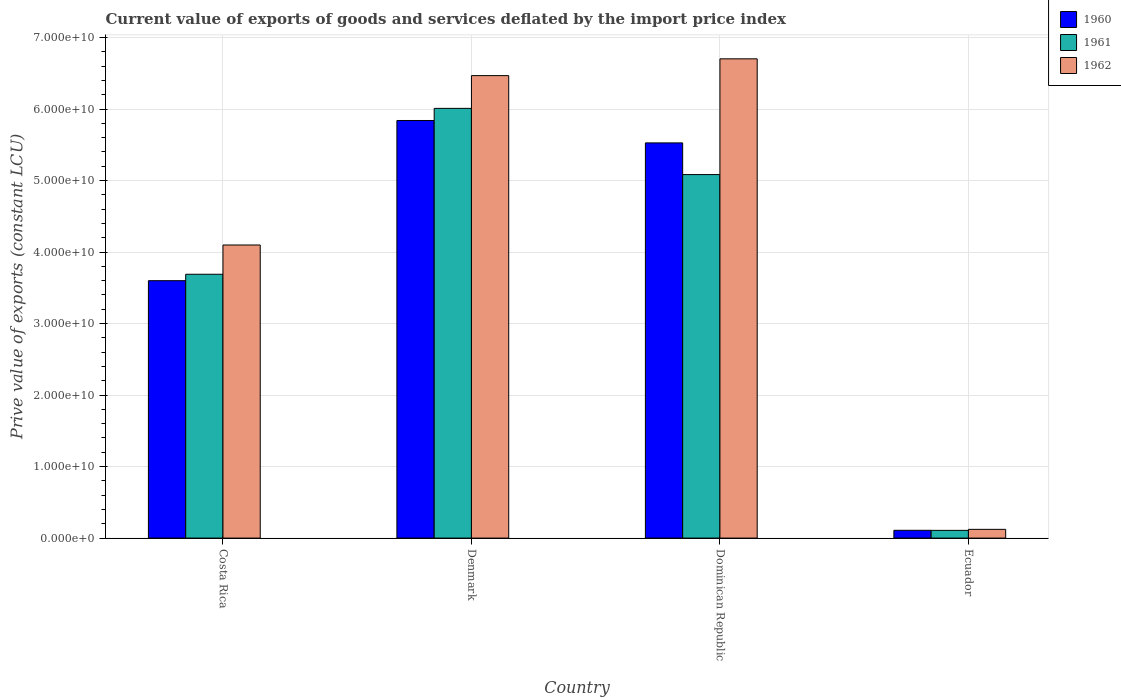Are the number of bars per tick equal to the number of legend labels?
Your answer should be very brief. Yes. Are the number of bars on each tick of the X-axis equal?
Provide a succinct answer. Yes. How many bars are there on the 3rd tick from the left?
Keep it short and to the point. 3. What is the label of the 4th group of bars from the left?
Make the answer very short. Ecuador. In how many cases, is the number of bars for a given country not equal to the number of legend labels?
Keep it short and to the point. 0. What is the prive value of exports in 1960 in Dominican Republic?
Provide a short and direct response. 5.53e+1. Across all countries, what is the maximum prive value of exports in 1962?
Offer a very short reply. 6.70e+1. Across all countries, what is the minimum prive value of exports in 1962?
Offer a very short reply. 1.22e+09. In which country was the prive value of exports in 1961 maximum?
Ensure brevity in your answer.  Denmark. In which country was the prive value of exports in 1962 minimum?
Offer a very short reply. Ecuador. What is the total prive value of exports in 1961 in the graph?
Your answer should be compact. 1.49e+11. What is the difference between the prive value of exports in 1960 in Denmark and that in Dominican Republic?
Offer a very short reply. 3.13e+09. What is the difference between the prive value of exports in 1960 in Denmark and the prive value of exports in 1962 in Costa Rica?
Make the answer very short. 1.74e+1. What is the average prive value of exports in 1960 per country?
Your answer should be compact. 3.77e+1. What is the difference between the prive value of exports of/in 1960 and prive value of exports of/in 1962 in Costa Rica?
Keep it short and to the point. -4.99e+09. What is the ratio of the prive value of exports in 1960 in Costa Rica to that in Ecuador?
Your answer should be compact. 33.09. Is the prive value of exports in 1962 in Costa Rica less than that in Denmark?
Give a very brief answer. Yes. What is the difference between the highest and the second highest prive value of exports in 1962?
Keep it short and to the point. 2.37e+1. What is the difference between the highest and the lowest prive value of exports in 1960?
Offer a very short reply. 5.73e+1. What does the 1st bar from the right in Denmark represents?
Provide a short and direct response. 1962. Is it the case that in every country, the sum of the prive value of exports in 1962 and prive value of exports in 1960 is greater than the prive value of exports in 1961?
Make the answer very short. Yes. How many bars are there?
Your answer should be very brief. 12. What is the difference between two consecutive major ticks on the Y-axis?
Give a very brief answer. 1.00e+1. Where does the legend appear in the graph?
Give a very brief answer. Top right. How are the legend labels stacked?
Give a very brief answer. Vertical. What is the title of the graph?
Give a very brief answer. Current value of exports of goods and services deflated by the import price index. Does "1984" appear as one of the legend labels in the graph?
Your response must be concise. No. What is the label or title of the X-axis?
Give a very brief answer. Country. What is the label or title of the Y-axis?
Your answer should be very brief. Prive value of exports (constant LCU). What is the Prive value of exports (constant LCU) of 1960 in Costa Rica?
Offer a very short reply. 3.60e+1. What is the Prive value of exports (constant LCU) in 1961 in Costa Rica?
Ensure brevity in your answer.  3.69e+1. What is the Prive value of exports (constant LCU) in 1962 in Costa Rica?
Offer a terse response. 4.10e+1. What is the Prive value of exports (constant LCU) in 1960 in Denmark?
Make the answer very short. 5.84e+1. What is the Prive value of exports (constant LCU) in 1961 in Denmark?
Your answer should be compact. 6.01e+1. What is the Prive value of exports (constant LCU) in 1962 in Denmark?
Offer a very short reply. 6.47e+1. What is the Prive value of exports (constant LCU) of 1960 in Dominican Republic?
Provide a succinct answer. 5.53e+1. What is the Prive value of exports (constant LCU) of 1961 in Dominican Republic?
Keep it short and to the point. 5.08e+1. What is the Prive value of exports (constant LCU) of 1962 in Dominican Republic?
Ensure brevity in your answer.  6.70e+1. What is the Prive value of exports (constant LCU) of 1960 in Ecuador?
Your answer should be very brief. 1.09e+09. What is the Prive value of exports (constant LCU) in 1961 in Ecuador?
Your response must be concise. 1.08e+09. What is the Prive value of exports (constant LCU) in 1962 in Ecuador?
Your response must be concise. 1.22e+09. Across all countries, what is the maximum Prive value of exports (constant LCU) in 1960?
Provide a succinct answer. 5.84e+1. Across all countries, what is the maximum Prive value of exports (constant LCU) in 1961?
Your answer should be compact. 6.01e+1. Across all countries, what is the maximum Prive value of exports (constant LCU) in 1962?
Your response must be concise. 6.70e+1. Across all countries, what is the minimum Prive value of exports (constant LCU) in 1960?
Ensure brevity in your answer.  1.09e+09. Across all countries, what is the minimum Prive value of exports (constant LCU) of 1961?
Provide a short and direct response. 1.08e+09. Across all countries, what is the minimum Prive value of exports (constant LCU) of 1962?
Make the answer very short. 1.22e+09. What is the total Prive value of exports (constant LCU) in 1960 in the graph?
Ensure brevity in your answer.  1.51e+11. What is the total Prive value of exports (constant LCU) in 1961 in the graph?
Keep it short and to the point. 1.49e+11. What is the total Prive value of exports (constant LCU) in 1962 in the graph?
Offer a very short reply. 1.74e+11. What is the difference between the Prive value of exports (constant LCU) of 1960 in Costa Rica and that in Denmark?
Offer a terse response. -2.24e+1. What is the difference between the Prive value of exports (constant LCU) in 1961 in Costa Rica and that in Denmark?
Give a very brief answer. -2.32e+1. What is the difference between the Prive value of exports (constant LCU) in 1962 in Costa Rica and that in Denmark?
Ensure brevity in your answer.  -2.37e+1. What is the difference between the Prive value of exports (constant LCU) of 1960 in Costa Rica and that in Dominican Republic?
Offer a terse response. -1.93e+1. What is the difference between the Prive value of exports (constant LCU) in 1961 in Costa Rica and that in Dominican Republic?
Make the answer very short. -1.39e+1. What is the difference between the Prive value of exports (constant LCU) of 1962 in Costa Rica and that in Dominican Republic?
Make the answer very short. -2.60e+1. What is the difference between the Prive value of exports (constant LCU) in 1960 in Costa Rica and that in Ecuador?
Your answer should be compact. 3.49e+1. What is the difference between the Prive value of exports (constant LCU) of 1961 in Costa Rica and that in Ecuador?
Offer a terse response. 3.58e+1. What is the difference between the Prive value of exports (constant LCU) in 1962 in Costa Rica and that in Ecuador?
Provide a succinct answer. 3.98e+1. What is the difference between the Prive value of exports (constant LCU) in 1960 in Denmark and that in Dominican Republic?
Keep it short and to the point. 3.13e+09. What is the difference between the Prive value of exports (constant LCU) in 1961 in Denmark and that in Dominican Republic?
Make the answer very short. 9.26e+09. What is the difference between the Prive value of exports (constant LCU) of 1962 in Denmark and that in Dominican Republic?
Your answer should be very brief. -2.35e+09. What is the difference between the Prive value of exports (constant LCU) in 1960 in Denmark and that in Ecuador?
Make the answer very short. 5.73e+1. What is the difference between the Prive value of exports (constant LCU) in 1961 in Denmark and that in Ecuador?
Provide a succinct answer. 5.90e+1. What is the difference between the Prive value of exports (constant LCU) in 1962 in Denmark and that in Ecuador?
Keep it short and to the point. 6.35e+1. What is the difference between the Prive value of exports (constant LCU) of 1960 in Dominican Republic and that in Ecuador?
Provide a short and direct response. 5.42e+1. What is the difference between the Prive value of exports (constant LCU) in 1961 in Dominican Republic and that in Ecuador?
Your response must be concise. 4.98e+1. What is the difference between the Prive value of exports (constant LCU) in 1962 in Dominican Republic and that in Ecuador?
Your answer should be very brief. 6.58e+1. What is the difference between the Prive value of exports (constant LCU) in 1960 in Costa Rica and the Prive value of exports (constant LCU) in 1961 in Denmark?
Your answer should be compact. -2.41e+1. What is the difference between the Prive value of exports (constant LCU) of 1960 in Costa Rica and the Prive value of exports (constant LCU) of 1962 in Denmark?
Provide a succinct answer. -2.87e+1. What is the difference between the Prive value of exports (constant LCU) in 1961 in Costa Rica and the Prive value of exports (constant LCU) in 1962 in Denmark?
Provide a short and direct response. -2.78e+1. What is the difference between the Prive value of exports (constant LCU) of 1960 in Costa Rica and the Prive value of exports (constant LCU) of 1961 in Dominican Republic?
Offer a terse response. -1.48e+1. What is the difference between the Prive value of exports (constant LCU) of 1960 in Costa Rica and the Prive value of exports (constant LCU) of 1962 in Dominican Republic?
Offer a very short reply. -3.10e+1. What is the difference between the Prive value of exports (constant LCU) of 1961 in Costa Rica and the Prive value of exports (constant LCU) of 1962 in Dominican Republic?
Ensure brevity in your answer.  -3.01e+1. What is the difference between the Prive value of exports (constant LCU) of 1960 in Costa Rica and the Prive value of exports (constant LCU) of 1961 in Ecuador?
Keep it short and to the point. 3.49e+1. What is the difference between the Prive value of exports (constant LCU) in 1960 in Costa Rica and the Prive value of exports (constant LCU) in 1962 in Ecuador?
Make the answer very short. 3.48e+1. What is the difference between the Prive value of exports (constant LCU) of 1961 in Costa Rica and the Prive value of exports (constant LCU) of 1962 in Ecuador?
Give a very brief answer. 3.57e+1. What is the difference between the Prive value of exports (constant LCU) of 1960 in Denmark and the Prive value of exports (constant LCU) of 1961 in Dominican Republic?
Make the answer very short. 7.57e+09. What is the difference between the Prive value of exports (constant LCU) of 1960 in Denmark and the Prive value of exports (constant LCU) of 1962 in Dominican Republic?
Your answer should be compact. -8.62e+09. What is the difference between the Prive value of exports (constant LCU) in 1961 in Denmark and the Prive value of exports (constant LCU) in 1962 in Dominican Republic?
Your response must be concise. -6.93e+09. What is the difference between the Prive value of exports (constant LCU) of 1960 in Denmark and the Prive value of exports (constant LCU) of 1961 in Ecuador?
Ensure brevity in your answer.  5.73e+1. What is the difference between the Prive value of exports (constant LCU) of 1960 in Denmark and the Prive value of exports (constant LCU) of 1962 in Ecuador?
Your answer should be very brief. 5.72e+1. What is the difference between the Prive value of exports (constant LCU) in 1961 in Denmark and the Prive value of exports (constant LCU) in 1962 in Ecuador?
Give a very brief answer. 5.89e+1. What is the difference between the Prive value of exports (constant LCU) in 1960 in Dominican Republic and the Prive value of exports (constant LCU) in 1961 in Ecuador?
Offer a terse response. 5.42e+1. What is the difference between the Prive value of exports (constant LCU) of 1960 in Dominican Republic and the Prive value of exports (constant LCU) of 1962 in Ecuador?
Offer a terse response. 5.40e+1. What is the difference between the Prive value of exports (constant LCU) of 1961 in Dominican Republic and the Prive value of exports (constant LCU) of 1962 in Ecuador?
Offer a terse response. 4.96e+1. What is the average Prive value of exports (constant LCU) of 1960 per country?
Offer a very short reply. 3.77e+1. What is the average Prive value of exports (constant LCU) of 1961 per country?
Your answer should be compact. 3.72e+1. What is the average Prive value of exports (constant LCU) of 1962 per country?
Provide a succinct answer. 4.35e+1. What is the difference between the Prive value of exports (constant LCU) of 1960 and Prive value of exports (constant LCU) of 1961 in Costa Rica?
Your response must be concise. -8.99e+08. What is the difference between the Prive value of exports (constant LCU) of 1960 and Prive value of exports (constant LCU) of 1962 in Costa Rica?
Give a very brief answer. -4.99e+09. What is the difference between the Prive value of exports (constant LCU) in 1961 and Prive value of exports (constant LCU) in 1962 in Costa Rica?
Offer a terse response. -4.09e+09. What is the difference between the Prive value of exports (constant LCU) in 1960 and Prive value of exports (constant LCU) in 1961 in Denmark?
Ensure brevity in your answer.  -1.70e+09. What is the difference between the Prive value of exports (constant LCU) in 1960 and Prive value of exports (constant LCU) in 1962 in Denmark?
Ensure brevity in your answer.  -6.28e+09. What is the difference between the Prive value of exports (constant LCU) of 1961 and Prive value of exports (constant LCU) of 1962 in Denmark?
Ensure brevity in your answer.  -4.58e+09. What is the difference between the Prive value of exports (constant LCU) of 1960 and Prive value of exports (constant LCU) of 1961 in Dominican Republic?
Your answer should be compact. 4.43e+09. What is the difference between the Prive value of exports (constant LCU) of 1960 and Prive value of exports (constant LCU) of 1962 in Dominican Republic?
Offer a very short reply. -1.18e+1. What is the difference between the Prive value of exports (constant LCU) of 1961 and Prive value of exports (constant LCU) of 1962 in Dominican Republic?
Your response must be concise. -1.62e+1. What is the difference between the Prive value of exports (constant LCU) in 1960 and Prive value of exports (constant LCU) in 1961 in Ecuador?
Keep it short and to the point. 7.73e+06. What is the difference between the Prive value of exports (constant LCU) of 1960 and Prive value of exports (constant LCU) of 1962 in Ecuador?
Provide a short and direct response. -1.34e+08. What is the difference between the Prive value of exports (constant LCU) in 1961 and Prive value of exports (constant LCU) in 1962 in Ecuador?
Offer a terse response. -1.41e+08. What is the ratio of the Prive value of exports (constant LCU) in 1960 in Costa Rica to that in Denmark?
Your answer should be very brief. 0.62. What is the ratio of the Prive value of exports (constant LCU) in 1961 in Costa Rica to that in Denmark?
Give a very brief answer. 0.61. What is the ratio of the Prive value of exports (constant LCU) of 1962 in Costa Rica to that in Denmark?
Ensure brevity in your answer.  0.63. What is the ratio of the Prive value of exports (constant LCU) of 1960 in Costa Rica to that in Dominican Republic?
Give a very brief answer. 0.65. What is the ratio of the Prive value of exports (constant LCU) in 1961 in Costa Rica to that in Dominican Republic?
Offer a very short reply. 0.73. What is the ratio of the Prive value of exports (constant LCU) in 1962 in Costa Rica to that in Dominican Republic?
Provide a succinct answer. 0.61. What is the ratio of the Prive value of exports (constant LCU) of 1960 in Costa Rica to that in Ecuador?
Provide a succinct answer. 33.09. What is the ratio of the Prive value of exports (constant LCU) of 1961 in Costa Rica to that in Ecuador?
Your answer should be compact. 34.15. What is the ratio of the Prive value of exports (constant LCU) in 1962 in Costa Rica to that in Ecuador?
Your answer should be very brief. 33.55. What is the ratio of the Prive value of exports (constant LCU) of 1960 in Denmark to that in Dominican Republic?
Your answer should be compact. 1.06. What is the ratio of the Prive value of exports (constant LCU) of 1961 in Denmark to that in Dominican Republic?
Keep it short and to the point. 1.18. What is the ratio of the Prive value of exports (constant LCU) in 1962 in Denmark to that in Dominican Republic?
Ensure brevity in your answer.  0.96. What is the ratio of the Prive value of exports (constant LCU) of 1960 in Denmark to that in Ecuador?
Ensure brevity in your answer.  53.67. What is the ratio of the Prive value of exports (constant LCU) of 1961 in Denmark to that in Ecuador?
Your response must be concise. 55.63. What is the ratio of the Prive value of exports (constant LCU) in 1962 in Denmark to that in Ecuador?
Provide a short and direct response. 52.94. What is the ratio of the Prive value of exports (constant LCU) of 1960 in Dominican Republic to that in Ecuador?
Make the answer very short. 50.79. What is the ratio of the Prive value of exports (constant LCU) of 1961 in Dominican Republic to that in Ecuador?
Your response must be concise. 47.06. What is the ratio of the Prive value of exports (constant LCU) in 1962 in Dominican Republic to that in Ecuador?
Offer a very short reply. 54.86. What is the difference between the highest and the second highest Prive value of exports (constant LCU) in 1960?
Your answer should be compact. 3.13e+09. What is the difference between the highest and the second highest Prive value of exports (constant LCU) in 1961?
Your answer should be compact. 9.26e+09. What is the difference between the highest and the second highest Prive value of exports (constant LCU) in 1962?
Offer a terse response. 2.35e+09. What is the difference between the highest and the lowest Prive value of exports (constant LCU) of 1960?
Keep it short and to the point. 5.73e+1. What is the difference between the highest and the lowest Prive value of exports (constant LCU) of 1961?
Make the answer very short. 5.90e+1. What is the difference between the highest and the lowest Prive value of exports (constant LCU) in 1962?
Make the answer very short. 6.58e+1. 